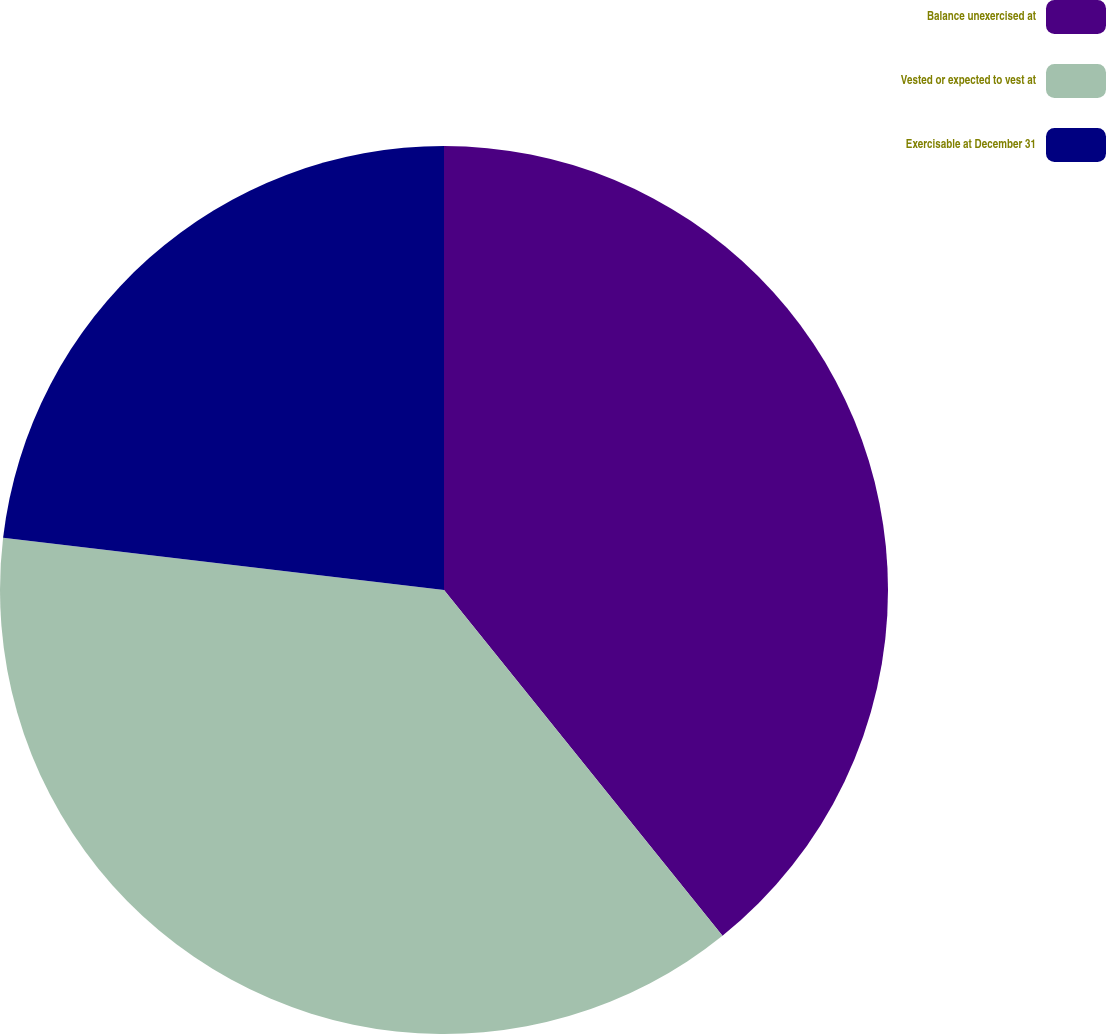Convert chart. <chart><loc_0><loc_0><loc_500><loc_500><pie_chart><fcel>Balance unexercised at<fcel>Vested or expected to vest at<fcel>Exercisable at December 31<nl><fcel>39.21%<fcel>37.67%<fcel>23.12%<nl></chart> 